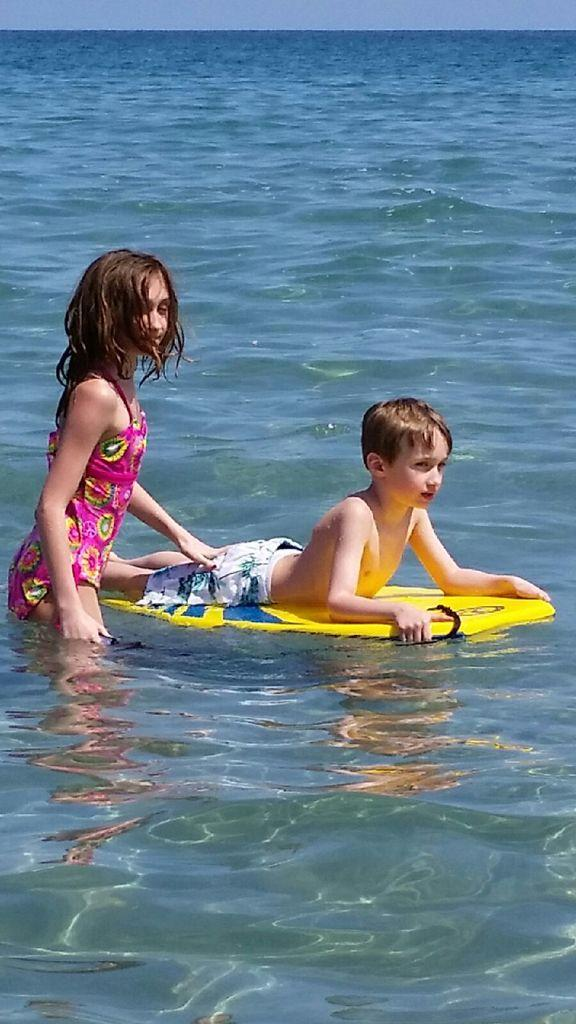What is the girl doing in the image? The girl is standing in the image. What is the boy doing in the image? The boy is lying on a surfboard in the image. Where is the surfboard located in the image? The surfboard is in the water. What type of yak can be seen grazing on the plant in the image? There is no yak or plant present in the image. What emotion does the girl feel when she sees the boy's shameful behavior in the image? There is no indication of shame or any specific emotion in the image. 